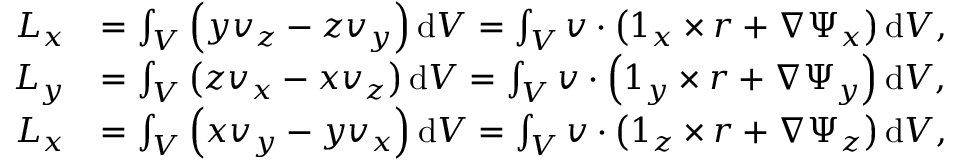Convert formula to latex. <formula><loc_0><loc_0><loc_500><loc_500>\begin{array} { r l } { L _ { x } } & { = \int _ { V } \left ( y v _ { z } - z v _ { y } \right ) d V = \int _ { V } v \cdot \left ( 1 _ { x } \times r + \nabla \Psi _ { x } \right ) d V , } \\ { L _ { y } } & { = \int _ { V } \left ( z v _ { x } - x v _ { z } \right ) d V = \int _ { V } v \cdot \left ( 1 _ { y } \times r + \nabla \Psi _ { y } \right ) d V , } \\ { L _ { x } } & { = \int _ { V } \left ( x v _ { y } - y v _ { x } \right ) d V = \int _ { V } v \cdot \left ( 1 _ { z } \times r + \nabla \Psi _ { z } \right ) d V , } \end{array}</formula> 